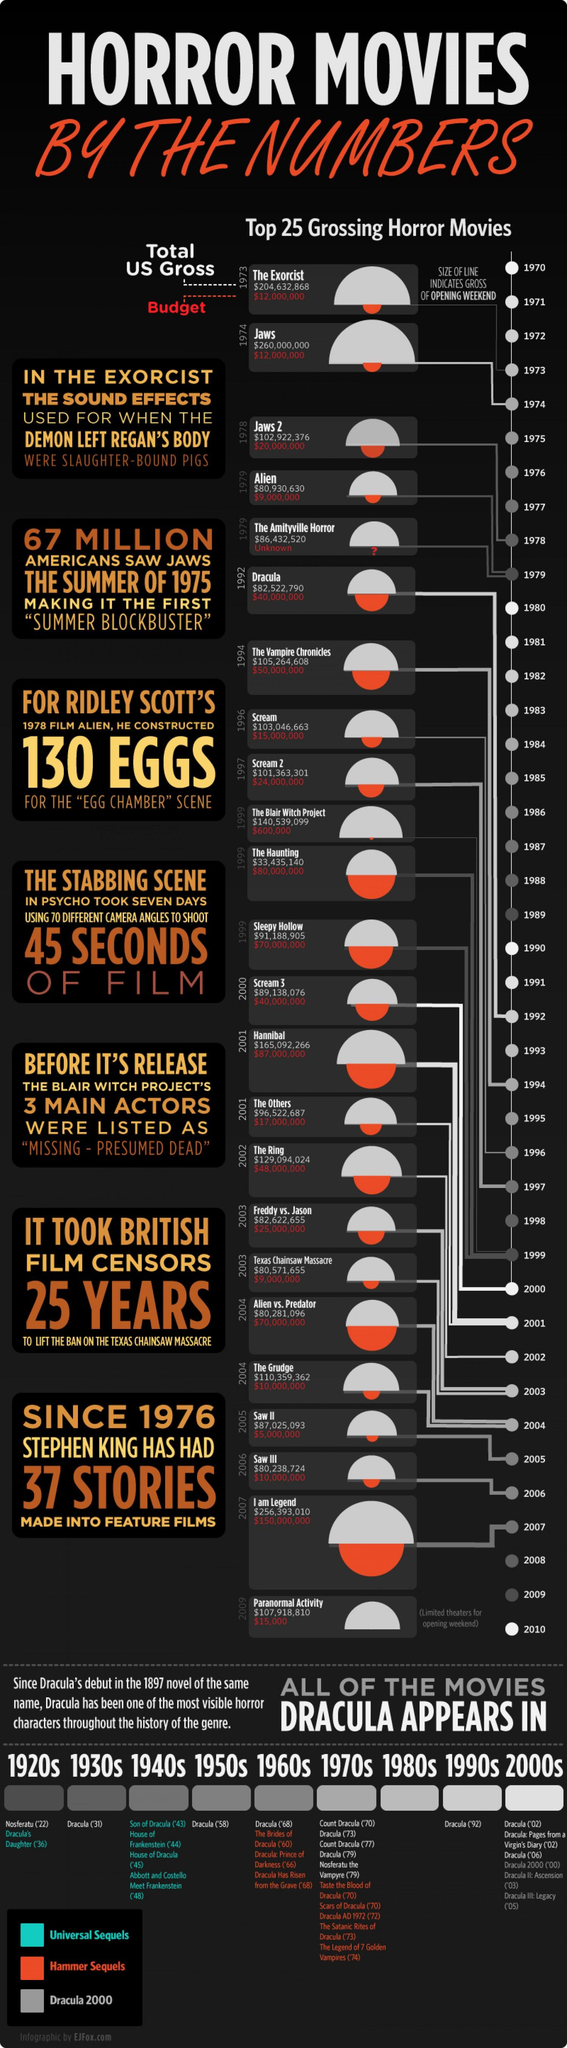List a handful of essential elements in this visual. The movie 'The Grudge' was released in 2004. The budget amount for the movie "Sleepy Hollow" was $70,000,000. The movie 'I Am Legend' was released in 2007. The total gross amount for the movie "Alien" in the United States is $80,930,630. The budget for the movie "The Ring" was $48,000,000. 